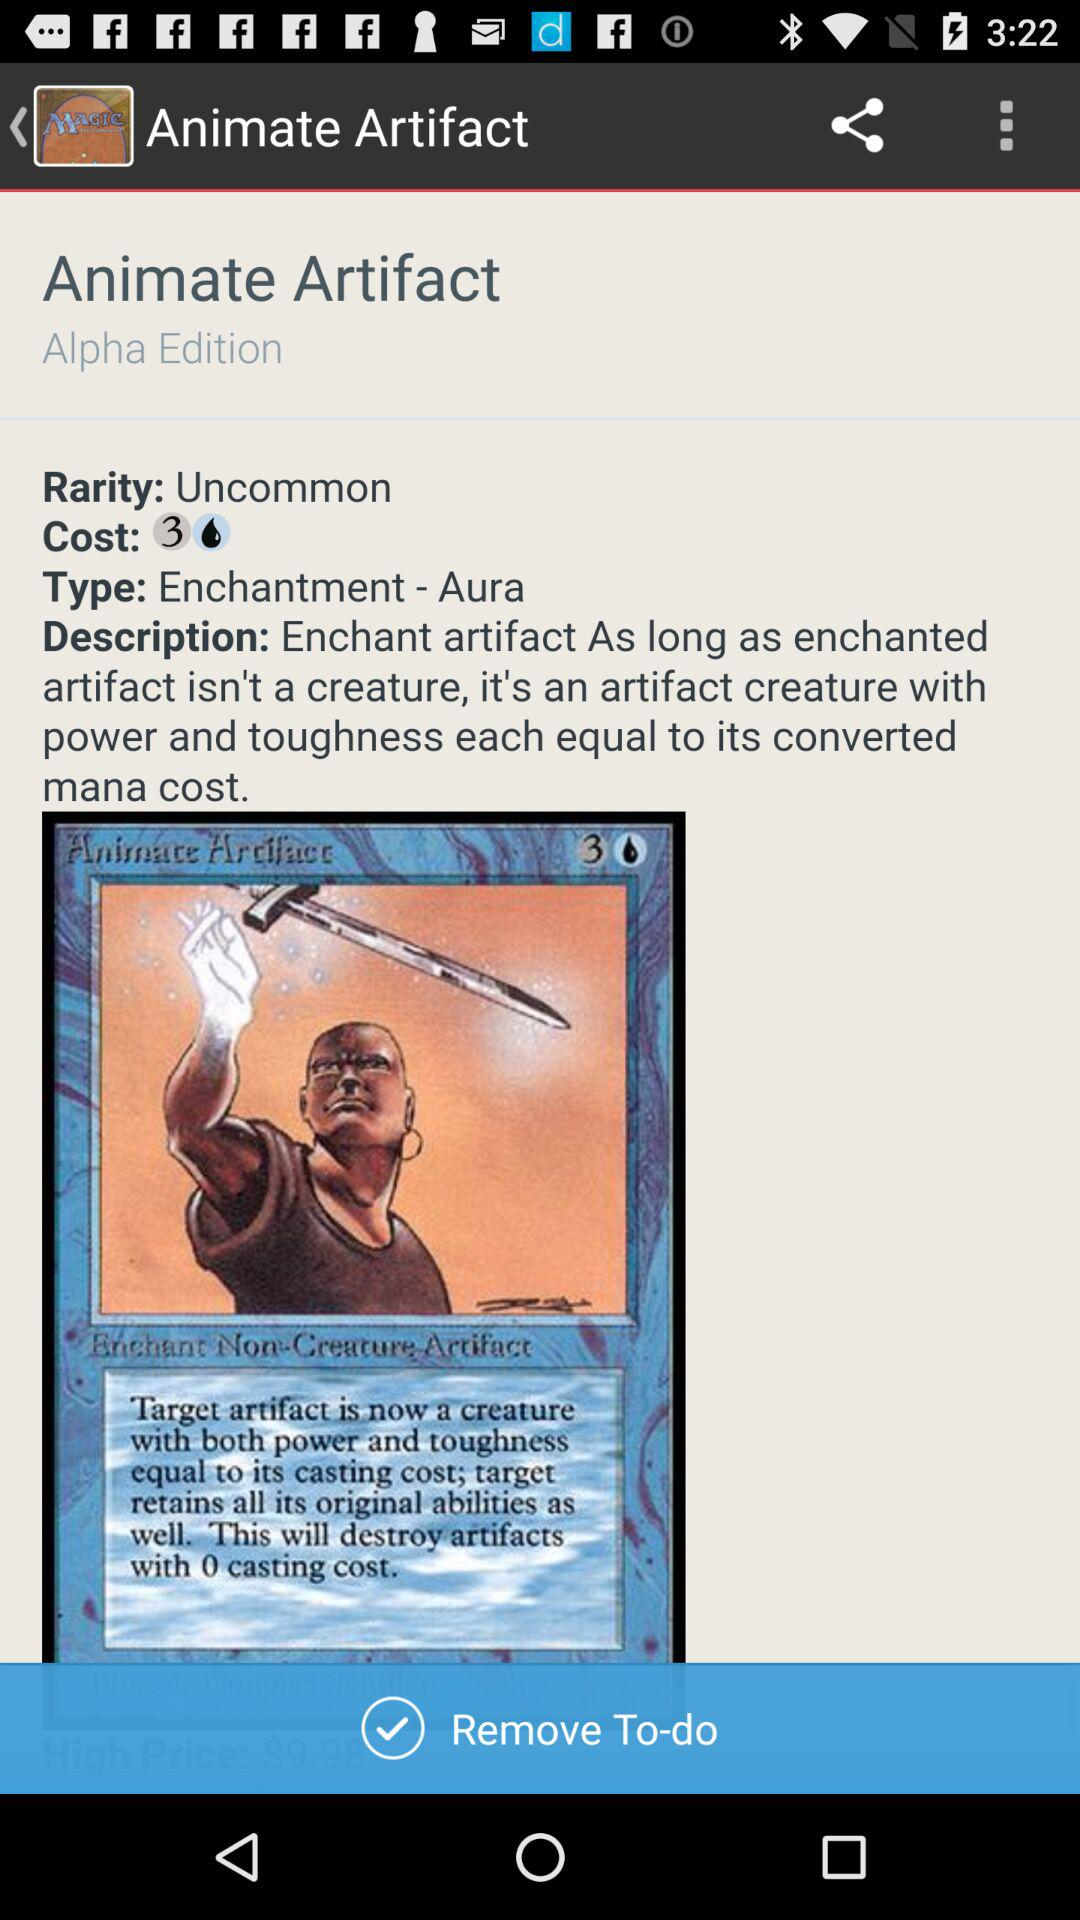What is the edition? The edition is "Alpha". 